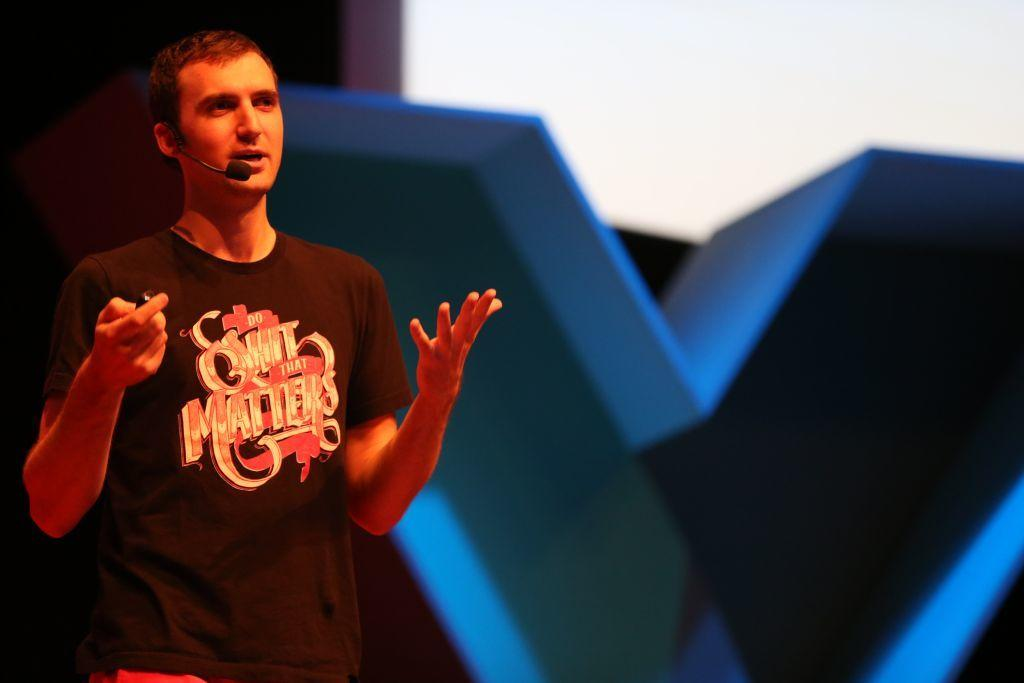Who is present in the image? There is a man in the image. What is the man doing in the image? The man is standing in the image. What object is the man holding in his hands? The man is holding a remote in his hands. What type of government is depicted in the image? There is no depiction of a government in the image; it features a man standing and holding a remote. How many cows are visible in the image? There are no cows present in the image. 